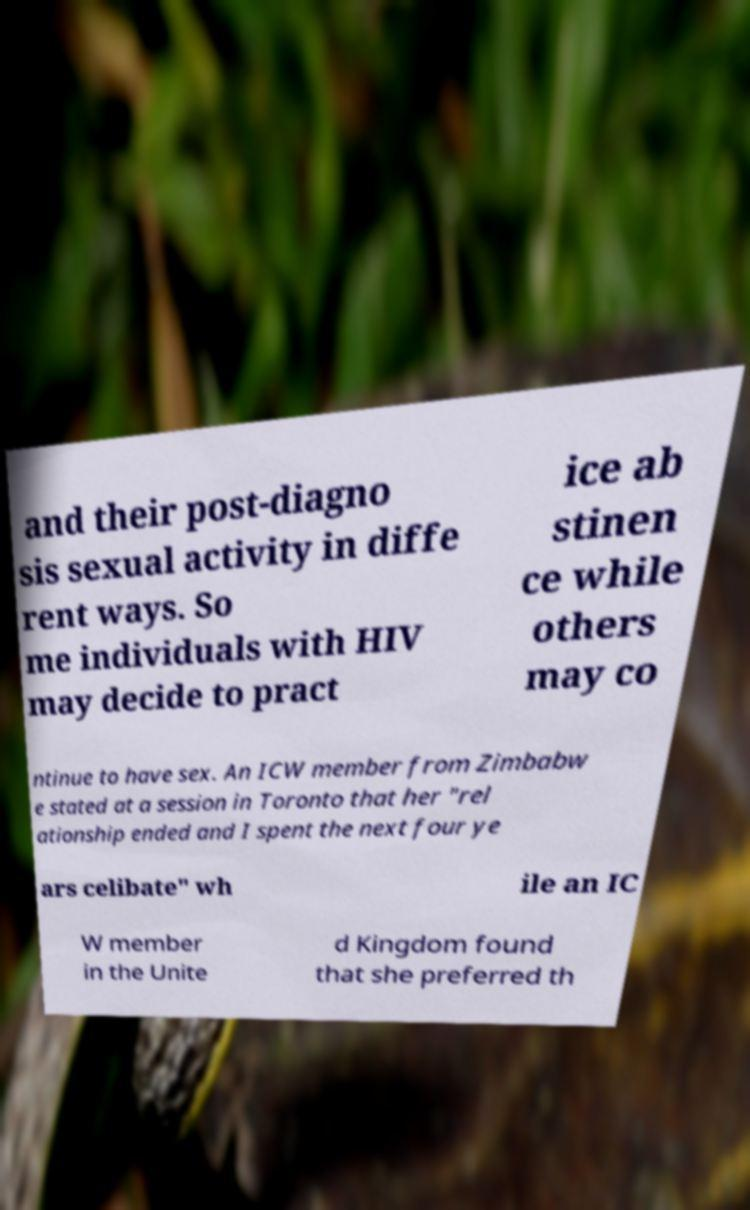Please read and relay the text visible in this image. What does it say? and their post-diagno sis sexual activity in diffe rent ways. So me individuals with HIV may decide to pract ice ab stinen ce while others may co ntinue to have sex. An ICW member from Zimbabw e stated at a session in Toronto that her "rel ationship ended and I spent the next four ye ars celibate" wh ile an IC W member in the Unite d Kingdom found that she preferred th 